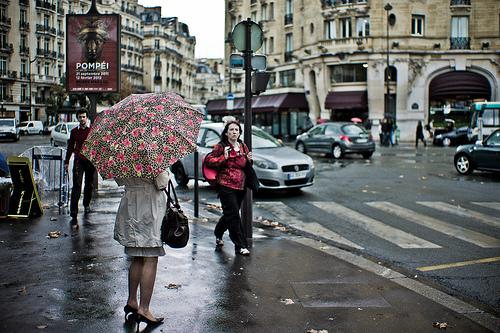Describe the most noticeable object in terms of color and size. A black and flowered umbrella is quite noticeable due to its large size and vibrant floral pattern. What are the different types of clothing and accessories present in the image? The clothing and accessories include a red jacket, black heels, black purse, woman's pink and black shirt, red and black blouse, black pants, black high heeled shoes, pink bag, black handbag, pink flowered umbrella, and a black and flowered umbrella. What is unique about the ground and what can be seen on it? The ground is wet, likely from rain, and there are white lines painted on it, a white crosswalk, and a leaf on the wet surface. What is the primary sentiment portrayed in the image? The primary sentiment portrayed in the image is a bustling, wet urban scene with people navigating the rain. Determine the number of vehicles and their colors in the image. There are six vehicles in the image, including a silver automobile, dark gray car, silver car on the road, dark color car, white van, and a car driving on the street. Explain the interaction between the woman holding an umbrella and her surroundings. The woman holding the umbrella is walking down the wet street in the rain while carrying a black purse and wearing high heels, trying to stay dry. Evaluate the image quality in terms of clarity and focus. The image quality is moderate with clear focus, but the image could be improved with greater detail and higher resolution. Describe the purpose and content of the advertisement and writing on the street sign. The advertisement features a red pompei poster; however, the content is not very clear from the details provided. The street sign has white writing on it, but the specific message is also unclear from the given information. How many objects are present in the image, and briefly mention their colors and details. There are 41 objects in the image, including a red pompei poster, black heels, silver automobile, woman in a red jacket, black purse, black and flowered umbrella, guy in black pants, woman with umbrella, city bus, woman walking, crosswalk, advertisement, street sign, dark gray car, awning, pink flowered umbrella, lady with pink bag, white writing on sign, silver car on road, maroon awnings, white van, black handbag, pink and black shirt, dark color car, white lines on road, woman with a black purse, umbrella with roses, white crosswalk, walking woman in rain, black high heeled shoes, man walking, red sign on street, car driving on street, red and black blouse, and a leaf on wet ground. What can be inferred about the weather based on the objects and their interaction in the image? It can be inferred that the weather is rainy and wet, as many people have umbrellas, the ground is wet, and individuals are dressed accordingly. Is there a crosswalk present in the image? Yes What is the color and design of the umbrella the woman is holding? Black and flowered Is there a man walking under a red and white striped umbrella? There is a woman holding an umbrella, not a man, and the umbrella is not described as red and white striped. This instruction is misleading because it wrongly attributes the gender and incorrectly describes the umbrella pattern. Is the man wearing a blue jacket and black pants in the image? There's a man wearing black pants, but there's no mention of a blue jacket. This instruction is misleading because it falsely adds an additional clothing item in a different color to the man. Is the woman holding the umbrella walking with or without shoes? With shoes What is the state of the ground during this scene? The ground is wet. Describe the atmosphere of the scene based on visible elements like the ground, the vehicles, the pedestrians, and their accessories. It is a rainy day in the city with wet ground, people carrying umbrellas, and vehicles driving down the street. Describe the object being held by the woman wearing the red and black blouse. A medium-sized black purse Can you see a yellow umbrella with flowers on it in the picture? The umbrella in the image is black and flowered, not yellow. This instruction is misleading because it falsely describes the color and pattern of the umbrella. Provide a comprehensive description of the umbrella with roses on it. It is a pink flowered umbrella, open, featuring roses as part of its design and being held by a woman walking in the rain. What kind of purse is the lady in the red jacket carrying? Unable to determine, as the lady in the red jacket is not carrying a purse in the information provided. Which vehicle is driving down the street: a silver automobile or a city bus? A silver automobile Determine if the man is walking down the sidewalk or the crosswalk. He is walking down the sidewalk. In the given image, identify the type of shoes a woman walking in the rain is wearing Black high-heeled shoes Is the woman carrying a pink purse in the image? There is a woman carrying a black purse, not a pink one. This instruction is misleading because it incorrectly associates the purse color with the woman in the image. What type of print is on the umbrella held by the lady carrying the black handbag? Roses Create a short narrative using the elements in the image such as the woman with an umbrella, the silver car turning, and the wet ground. On a rainy day, a woman walks down the street holding her flowered umbrella while a silver car turns left nearby. Puddles cover the wet ground painted with white lines forming a crosswalk. Explain the orientation of the white lines on the road. The white lines are painted as part of a crosswalk. Describe the scene in the image with a focus on the woman walking in the rain. A woman walking down the street in the rain, holding an umbrella with roses on it, wearing a red and black blouse, high heels, and carrying a black purse. Can you spot a small-sized green purse in this photo? The purse mentioned in the image is medium-sized and black, not small and green. This instruction is misleading because it incorrectly describes the size and color of the purse in the image. What causes the white lines painted on the road to be interrupted? They are part of a crosswalk and are interrupted to form zebra stripes. Is there a blue car turning right on the street? The silver car is turning left, not a blue car turning right. This instruction is misleading because it inaccurately describes the car color and its direction of movement. Identify the event taking place involving the silver car on the road. The silver car is turning left. What is the color of the sign at the top-left corner of the image? Red Provide a detailed description of the woman wearing high heels. The woman is walking down the street in the rain, wearing black high-heeled shoes, a red and black blouse, holding a black and flowered umbrella, and carrying a black purse. 